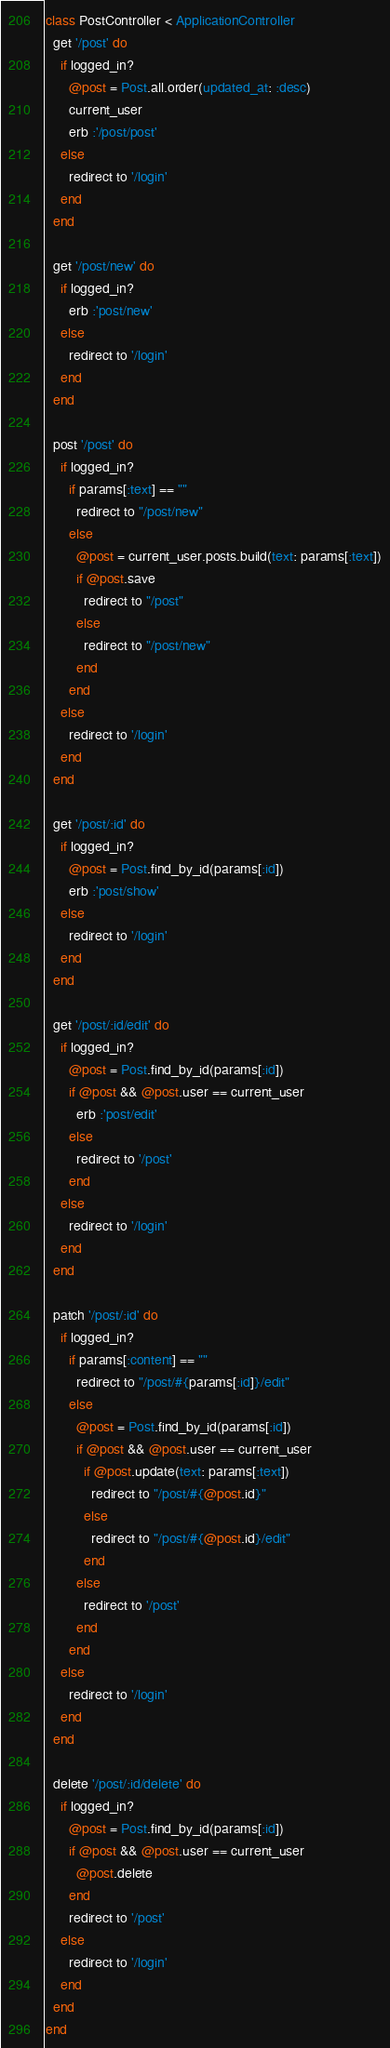Convert code to text. <code><loc_0><loc_0><loc_500><loc_500><_Ruby_>class PostController < ApplicationController
  get '/post' do
    if logged_in?
      @post = Post.all.order(updated_at: :desc)
      current_user
      erb :'/post/post'
    else
      redirect to '/login'
    end
  end

  get '/post/new' do
    if logged_in?
      erb :'post/new'
    else
      redirect to '/login'
    end
  end

  post '/post' do
    if logged_in?
      if params[:text] == ""
        redirect to "/post/new"
      else
        @post = current_user.posts.build(text: params[:text])
        if @post.save
          redirect to "/post"
        else
          redirect to "/post/new"
        end
      end
    else
      redirect to '/login'
    end
  end

  get '/post/:id' do
    if logged_in?
      @post = Post.find_by_id(params[:id])
      erb :'post/show'
    else
      redirect to '/login'
    end
  end

  get '/post/:id/edit' do
    if logged_in?
      @post = Post.find_by_id(params[:id])
      if @post && @post.user == current_user
        erb :'post/edit'
      else
        redirect to '/post'
      end
    else
      redirect to '/login'
    end
  end

  patch '/post/:id' do
    if logged_in?
      if params[:content] == ""
        redirect to "/post/#{params[:id]}/edit"
      else
        @post = Post.find_by_id(params[:id])
        if @post && @post.user == current_user
          if @post.update(text: params[:text])
            redirect to "/post/#{@post.id}"
          else
            redirect to "/post/#{@post.id}/edit"
          end
        else
          redirect to '/post'
        end
      end
    else
      redirect to '/login'
    end
  end

  delete '/post/:id/delete' do
    if logged_in?
      @post = Post.find_by_id(params[:id])
      if @post && @post.user == current_user
        @post.delete
      end
      redirect to '/post'
    else
      redirect to '/login'
    end
  end
end</code> 